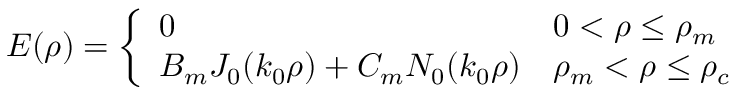Convert formula to latex. <formula><loc_0><loc_0><loc_500><loc_500>E ( \rho ) = \left \{ \begin{array} { l l } { 0 } & { 0 < \rho \leq \rho _ { m } } \\ { B _ { m } J _ { 0 } ( k _ { 0 } \rho ) + C _ { m } N _ { 0 } ( k _ { 0 } \rho ) } & { \rho _ { m } < \rho \leq \rho _ { c } } \end{array}</formula> 